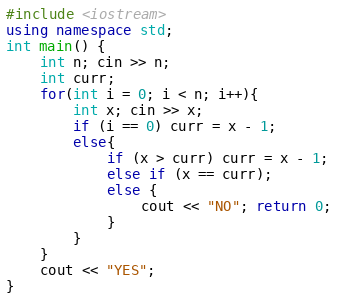<code> <loc_0><loc_0><loc_500><loc_500><_C++_>#include <iostream>
using namespace std;
int main() {
	int n; cin >> n;
	int curr;
	for(int i = 0; i < n; i++){
		int x; cin >> x;
		if (i == 0) curr = x - 1;
		else{
			if (x > curr) curr = x - 1;
			else if (x == curr);
			else {
				cout << "NO"; return 0;
			}
		}
	}
	cout << "YES";
}</code> 